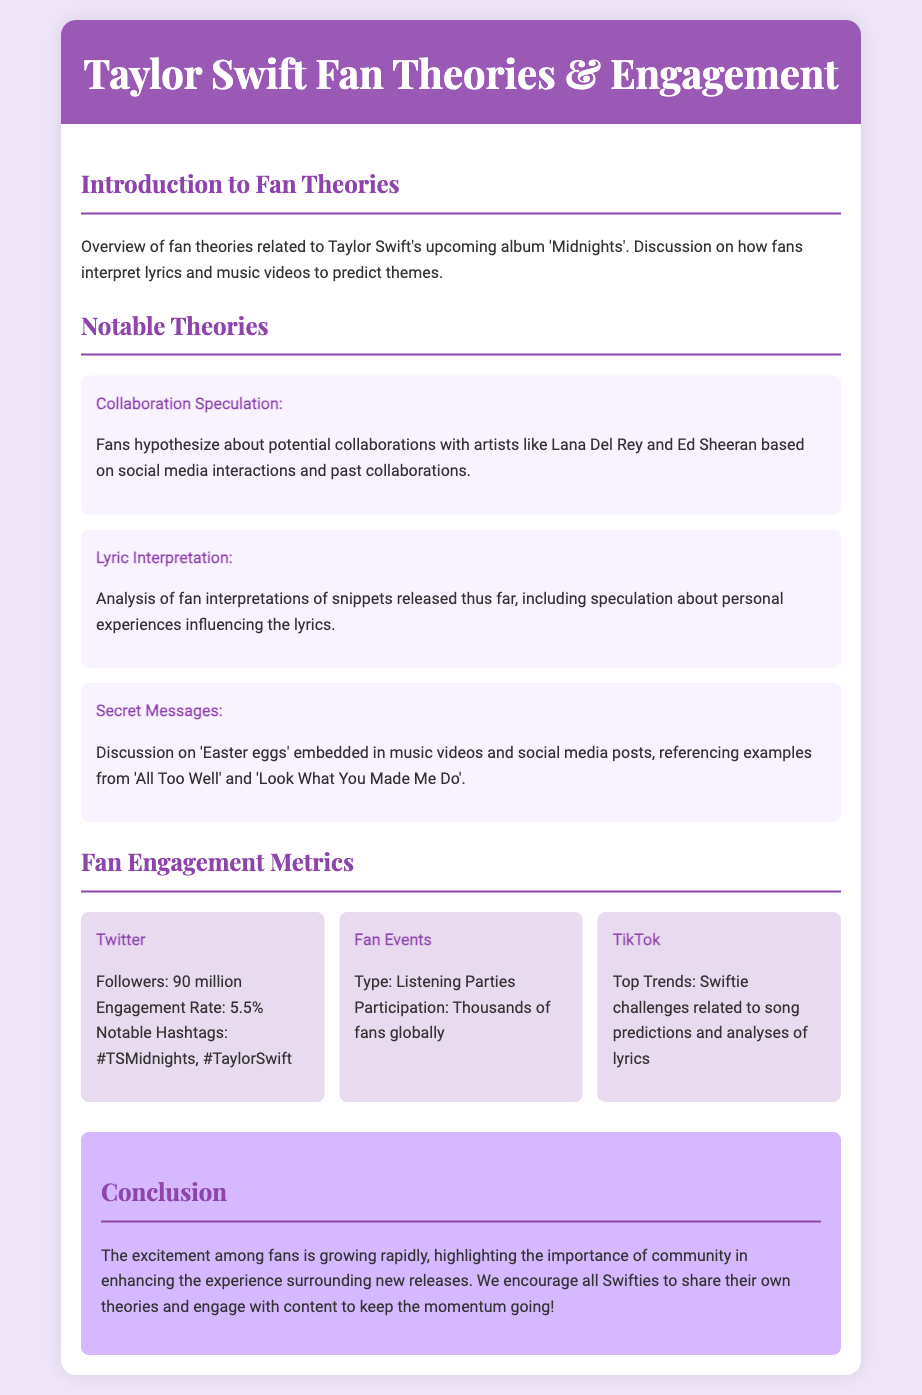What is the title of the upcoming album discussed in the document? The document mentions the upcoming album as 'Midnights'.
Answer: 'Midnights' How many followers does Taylor Swift have on Twitter? The document states that Taylor Swift has 90 million followers on Twitter.
Answer: 90 million What is the engagement rate on Twitter? The engagement rate mentioned for Twitter in the document is 5.5%.
Answer: 5.5% Who are the artists speculated for collaboration? The document references Lana Del Rey and Ed Sheeran as the artists for collaboration speculation.
Answer: Lana Del Rey and Ed Sheeran What type of fan event is mentioned in the metrics section? The document describes the fan event type as Listening Parties.
Answer: Listening Parties Which social media platform has top trends related to Swiftie challenges? The document indicates that TikTok has top trends related to Swiftie challenges.
Answer: TikTok What is one of the notable hashtags listed in the document? The document lists '#TSMidnights' as one of the notable hashtags.
Answer: #TSMidnights What is the theme of the theories discussed in the introduction? The introduction discusses interpreting lyrics and music videos to predict themes related to Taylor Swift's upcoming album.
Answer: Predict themes What is emphasized as important in the conclusion? The conclusion emphasizes the importance of community in enhancing the experience surrounding new releases.
Answer: Community 